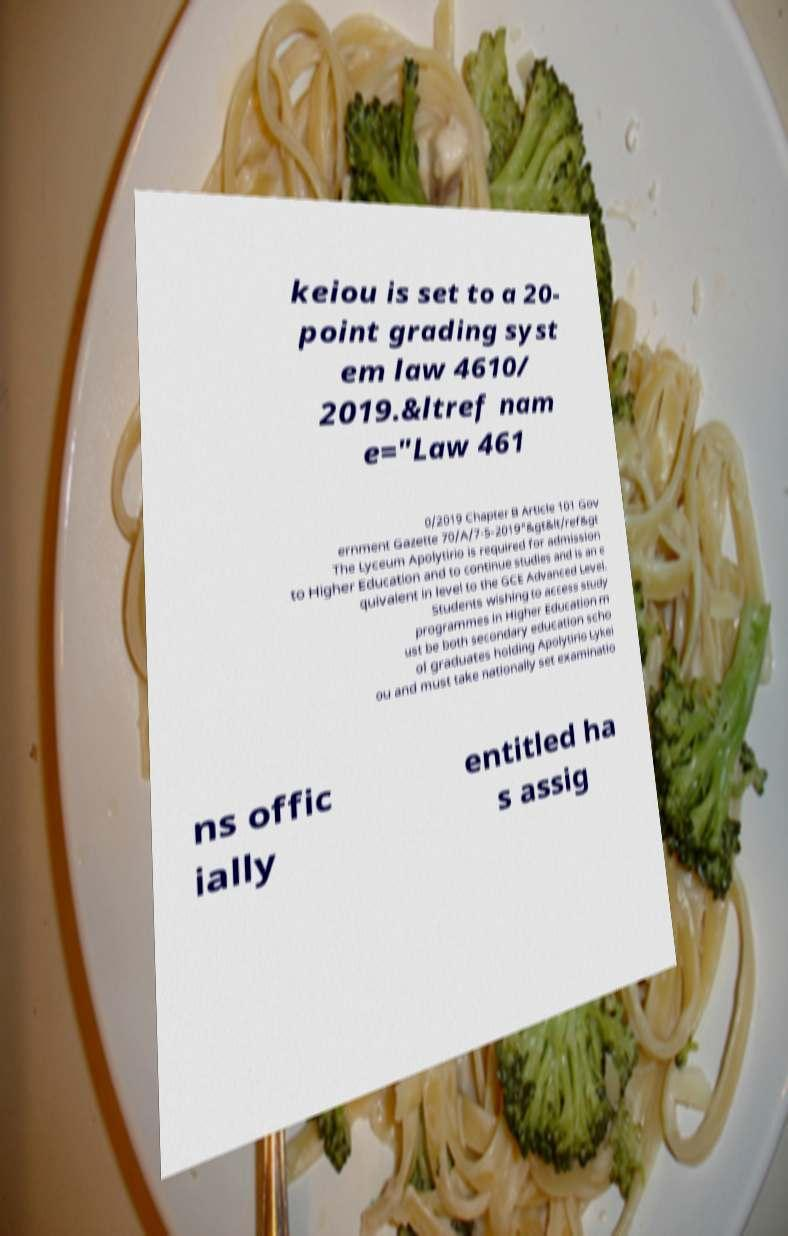For documentation purposes, I need the text within this image transcribed. Could you provide that? keiou is set to a 20- point grading syst em law 4610/ 2019.&ltref nam e="Law 461 0/2019 Chapter B Article 101 Gov ernment Gazette 70/A/7-5-2019"&gt&lt/ref&gt The Lyceum Apolytirio is required for admission to Higher Education and to continue studies and is an e quivalent in level to the GCE Advanced Level. Students wishing to access study programmes in Higher Education m ust be both secondary education scho ol graduates holding Apolytirio Lykei ou and must take nationally set examinatio ns offic ially entitled ha s assig 